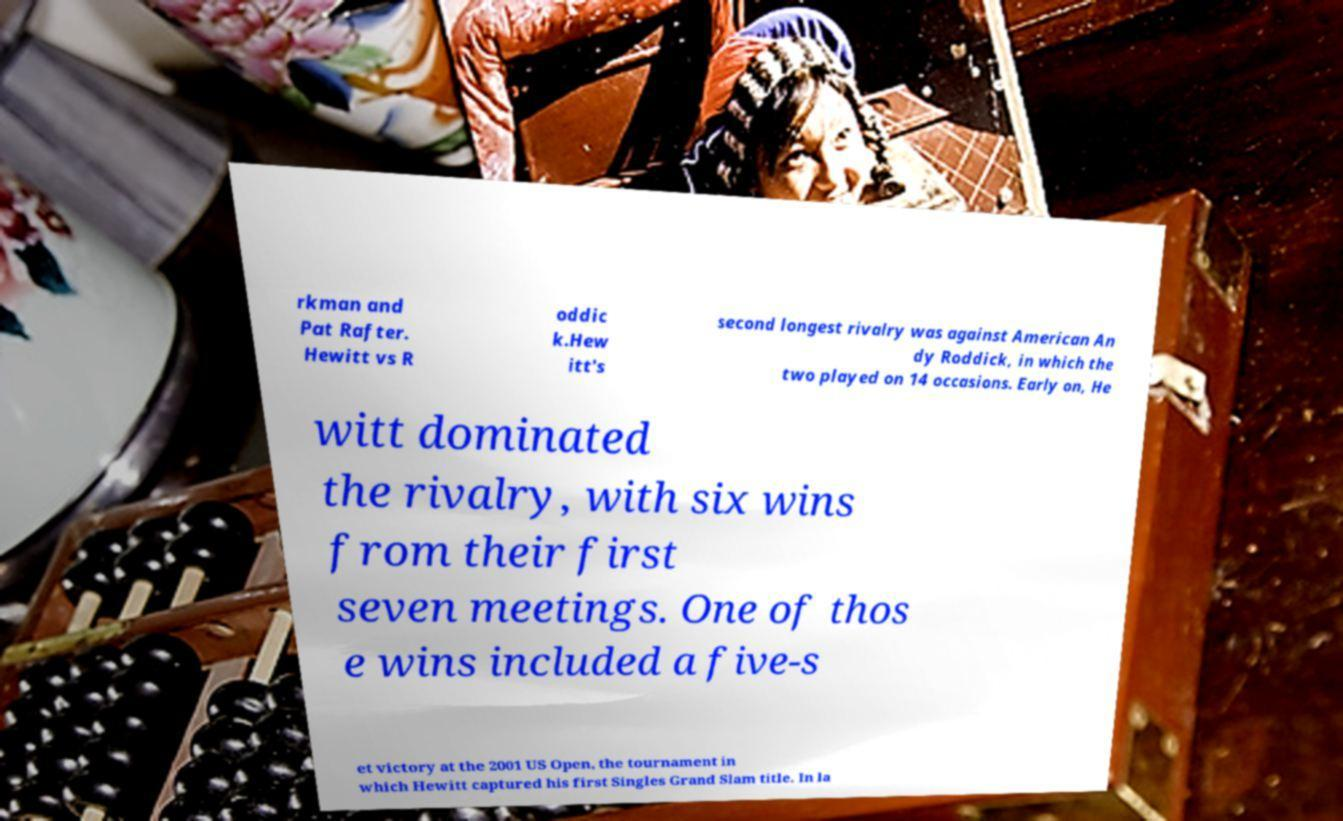For documentation purposes, I need the text within this image transcribed. Could you provide that? rkman and Pat Rafter. Hewitt vs R oddic k.Hew itt's second longest rivalry was against American An dy Roddick, in which the two played on 14 occasions. Early on, He witt dominated the rivalry, with six wins from their first seven meetings. One of thos e wins included a five-s et victory at the 2001 US Open, the tournament in which Hewitt captured his first Singles Grand Slam title. In la 